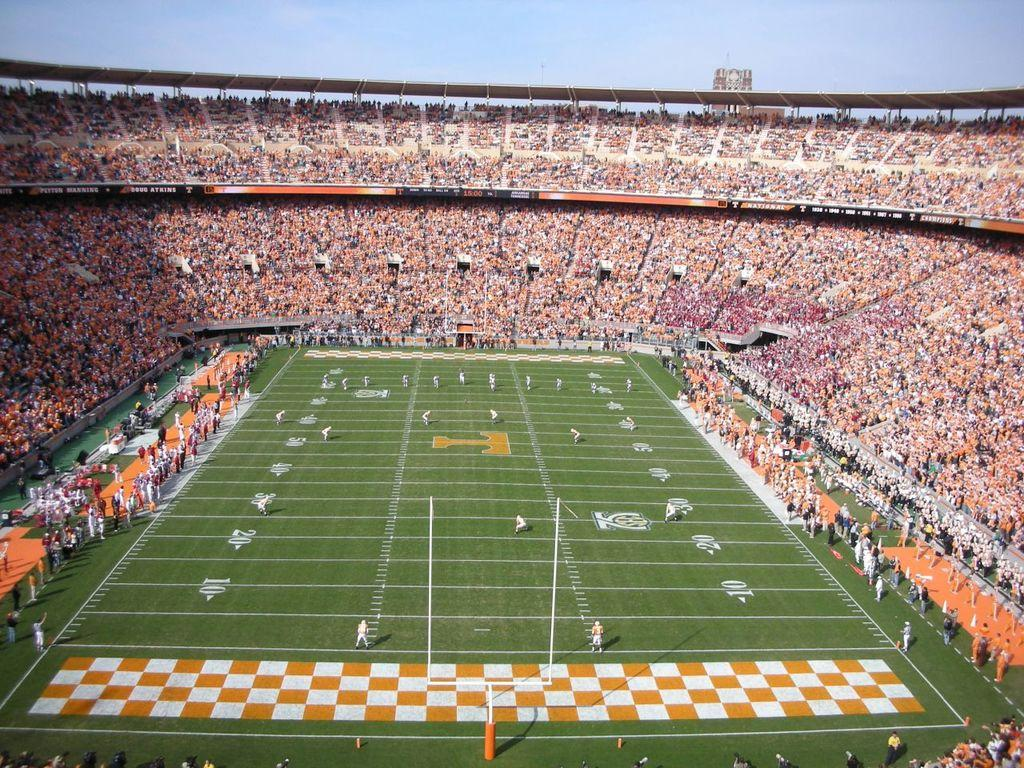<image>
Create a compact narrative representing the image presented. A football field features an orange "T" in the middle of it. 